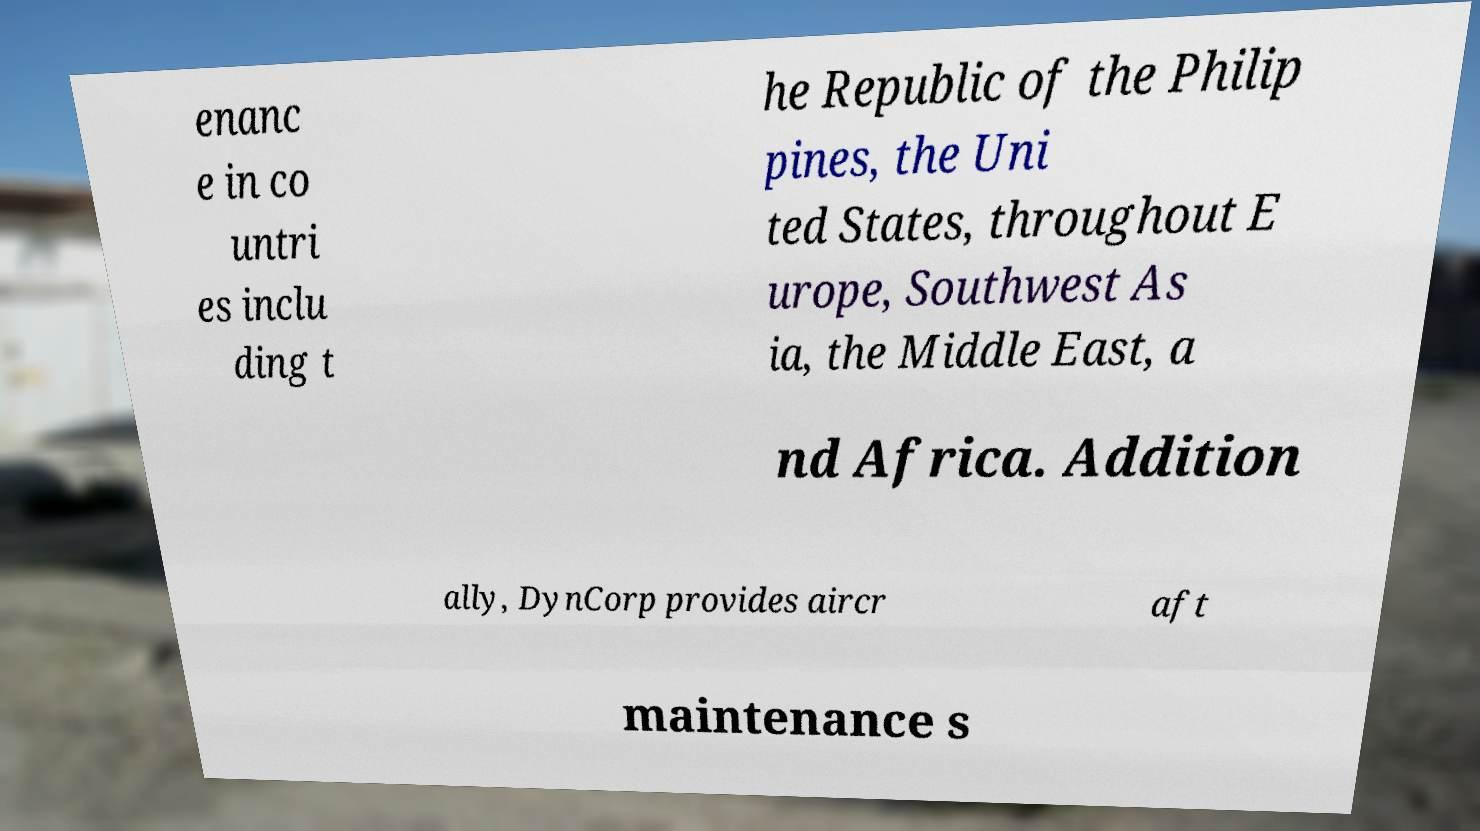Could you extract and type out the text from this image? enanc e in co untri es inclu ding t he Republic of the Philip pines, the Uni ted States, throughout E urope, Southwest As ia, the Middle East, a nd Africa. Addition ally, DynCorp provides aircr aft maintenance s 